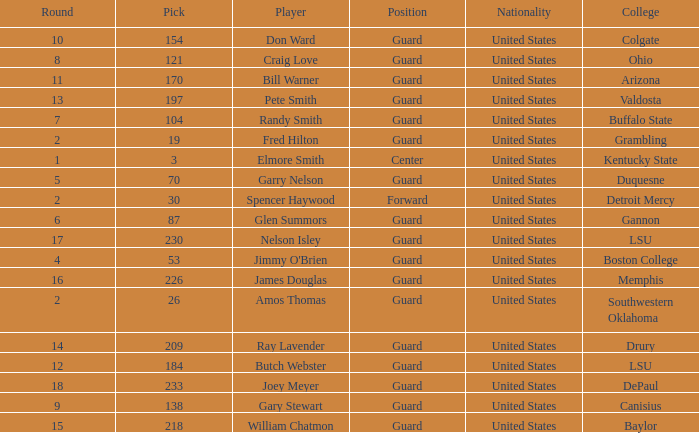WHAT ROUND HAS A GUARD POSITION AT OHIO COLLEGE? 8.0. 